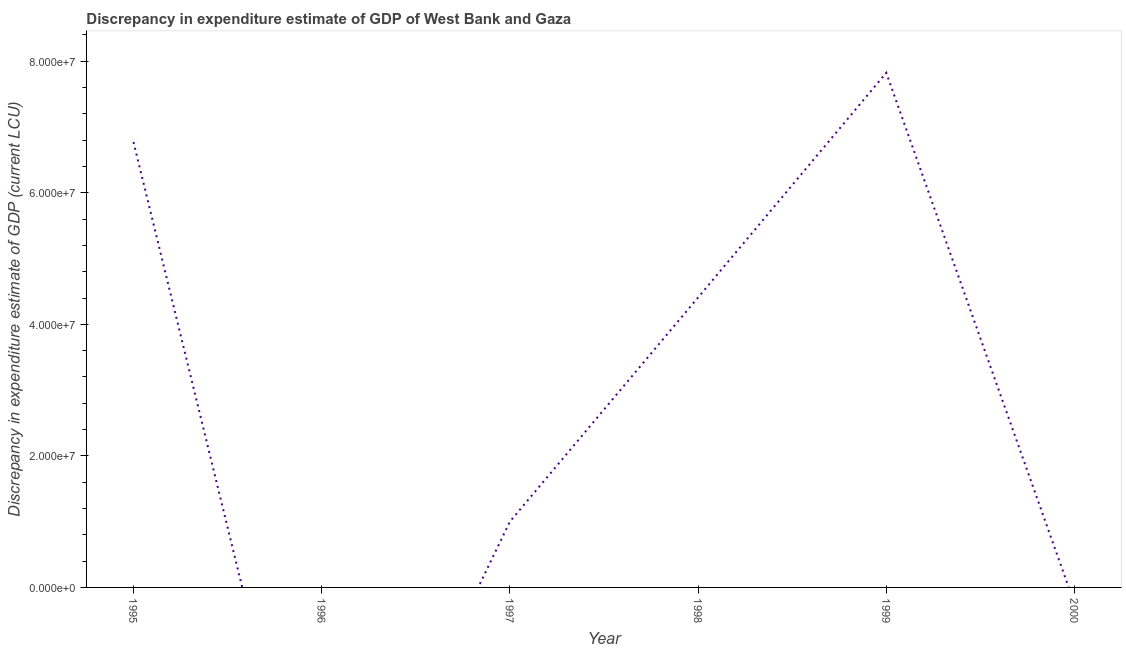What is the discrepancy in expenditure estimate of gdp in 2000?
Ensure brevity in your answer.  0. Across all years, what is the maximum discrepancy in expenditure estimate of gdp?
Offer a very short reply. 7.82e+07. Across all years, what is the minimum discrepancy in expenditure estimate of gdp?
Your answer should be compact. 0. What is the sum of the discrepancy in expenditure estimate of gdp?
Offer a terse response. 2.00e+08. What is the difference between the discrepancy in expenditure estimate of gdp in 1995 and 1998?
Your answer should be very brief. 2.36e+07. What is the average discrepancy in expenditure estimate of gdp per year?
Offer a terse response. 3.33e+07. What is the median discrepancy in expenditure estimate of gdp?
Your answer should be very brief. 2.70e+07. What is the ratio of the discrepancy in expenditure estimate of gdp in 1997 to that in 1999?
Provide a succinct answer. 0.13. What is the difference between the highest and the second highest discrepancy in expenditure estimate of gdp?
Ensure brevity in your answer.  1.05e+07. What is the difference between the highest and the lowest discrepancy in expenditure estimate of gdp?
Offer a very short reply. 7.82e+07. Does the discrepancy in expenditure estimate of gdp monotonically increase over the years?
Your answer should be compact. No. How many lines are there?
Provide a succinct answer. 1. Does the graph contain grids?
Give a very brief answer. No. What is the title of the graph?
Keep it short and to the point. Discrepancy in expenditure estimate of GDP of West Bank and Gaza. What is the label or title of the Y-axis?
Offer a terse response. Discrepancy in expenditure estimate of GDP (current LCU). What is the Discrepancy in expenditure estimate of GDP (current LCU) in 1995?
Ensure brevity in your answer.  6.77e+07. What is the Discrepancy in expenditure estimate of GDP (current LCU) in 1997?
Your answer should be compact. 1.00e+07. What is the Discrepancy in expenditure estimate of GDP (current LCU) of 1998?
Your answer should be very brief. 4.41e+07. What is the Discrepancy in expenditure estimate of GDP (current LCU) of 1999?
Provide a short and direct response. 7.82e+07. What is the difference between the Discrepancy in expenditure estimate of GDP (current LCU) in 1995 and 1997?
Provide a succinct answer. 5.77e+07. What is the difference between the Discrepancy in expenditure estimate of GDP (current LCU) in 1995 and 1998?
Provide a short and direct response. 2.36e+07. What is the difference between the Discrepancy in expenditure estimate of GDP (current LCU) in 1995 and 1999?
Keep it short and to the point. -1.05e+07. What is the difference between the Discrepancy in expenditure estimate of GDP (current LCU) in 1997 and 1998?
Your answer should be compact. -3.41e+07. What is the difference between the Discrepancy in expenditure estimate of GDP (current LCU) in 1997 and 1999?
Give a very brief answer. -6.82e+07. What is the difference between the Discrepancy in expenditure estimate of GDP (current LCU) in 1998 and 1999?
Offer a very short reply. -3.42e+07. What is the ratio of the Discrepancy in expenditure estimate of GDP (current LCU) in 1995 to that in 1997?
Provide a short and direct response. 6.77. What is the ratio of the Discrepancy in expenditure estimate of GDP (current LCU) in 1995 to that in 1998?
Make the answer very short. 1.54. What is the ratio of the Discrepancy in expenditure estimate of GDP (current LCU) in 1995 to that in 1999?
Make the answer very short. 0.87. What is the ratio of the Discrepancy in expenditure estimate of GDP (current LCU) in 1997 to that in 1998?
Provide a short and direct response. 0.23. What is the ratio of the Discrepancy in expenditure estimate of GDP (current LCU) in 1997 to that in 1999?
Ensure brevity in your answer.  0.13. What is the ratio of the Discrepancy in expenditure estimate of GDP (current LCU) in 1998 to that in 1999?
Offer a very short reply. 0.56. 